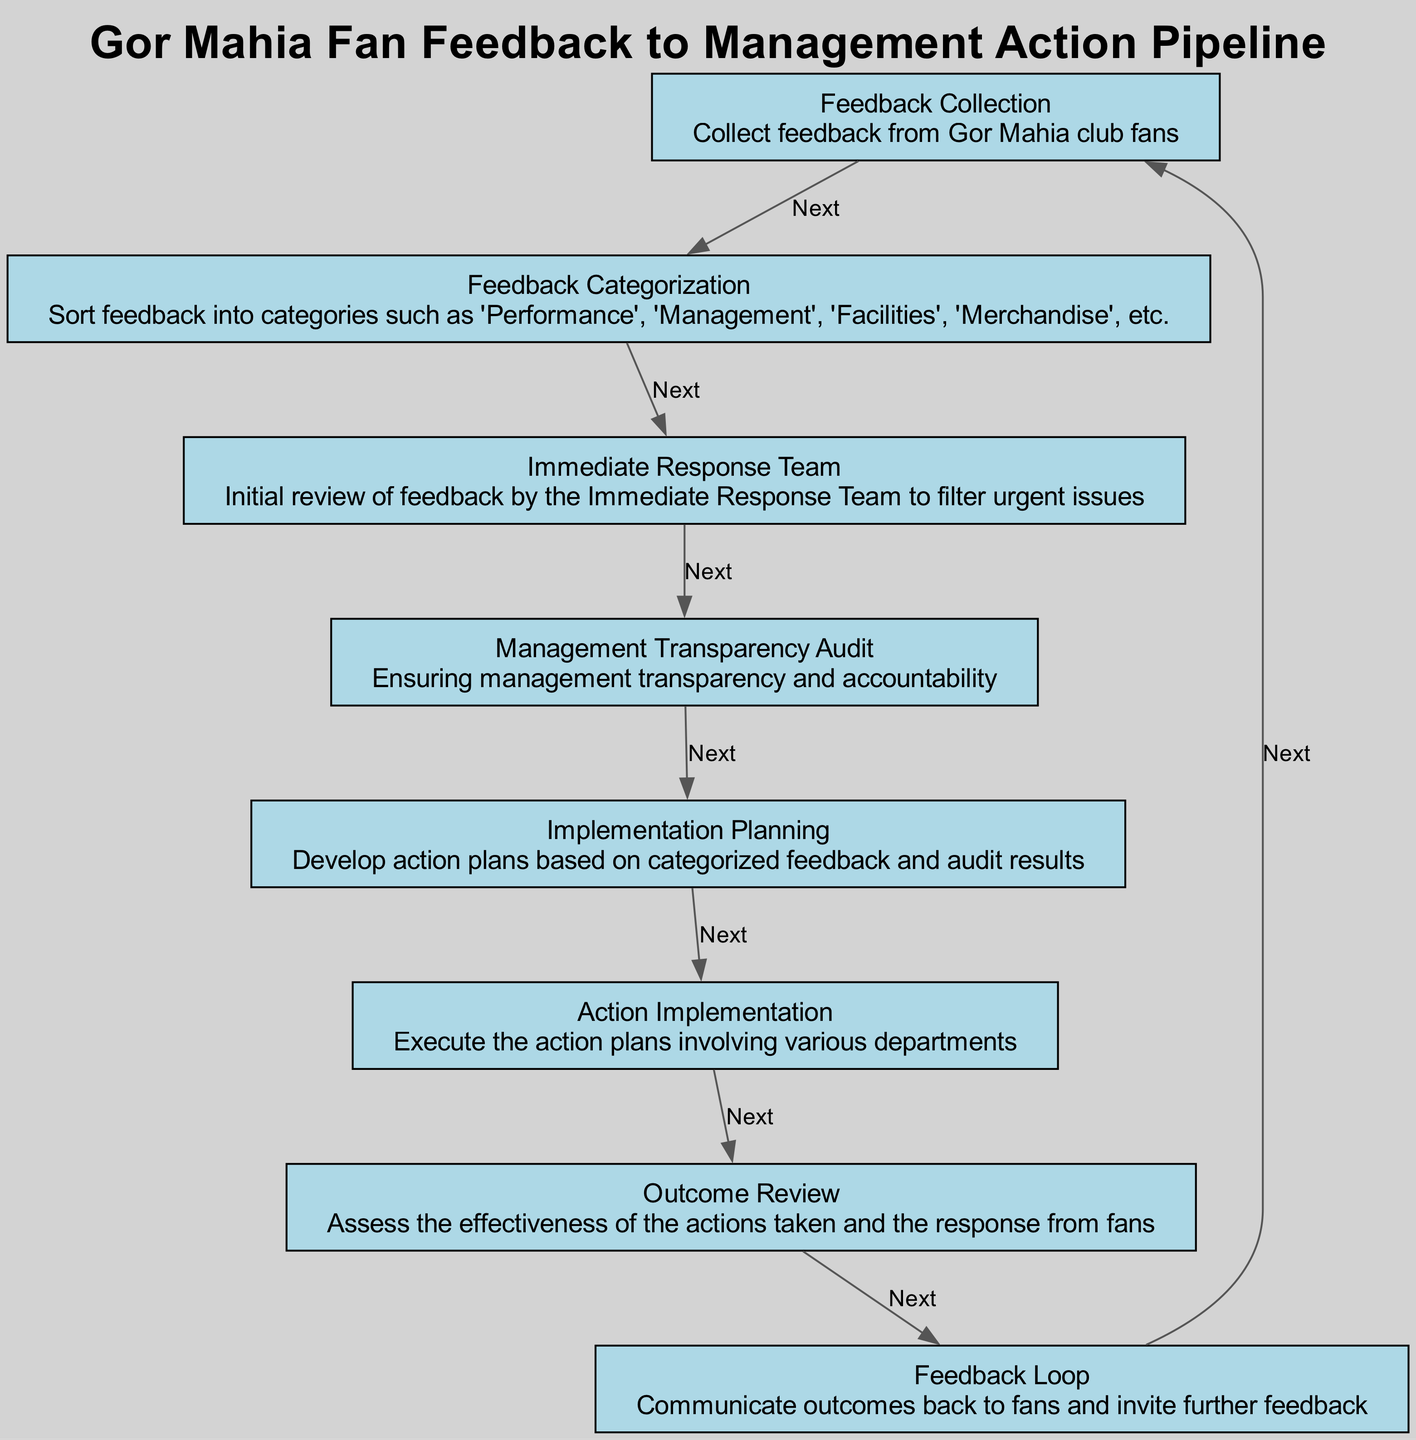What is the first step in the feedback pipeline? The first step in the feedback pipeline, as indicated in the diagram, is "Feedback Collection." This is the initial phase where feedback from Gor Mahia club fans is gathered.
Answer: Feedback Collection How many steps are there in the pipeline? The diagram shows a total of 8 steps represented by the elements going from feedback collection to feedback loop. Each element corresponds to a unique step in the process.
Answer: 8 What is the purpose of the Management Transparency Audit? The Management Transparency Audit, noted in the diagram, is to ensure management transparency and accountability in responding to fan feedback. This step seeks to build trust with the fans by making sure management acts transparently.
Answer: Ensuring management transparency and accountability Which step comes after Action Implementation? Action Implementation is followed by Outcome Review, where the effectiveness of the implemented actions is assessed alongside fan responses. This connection shows the flow of feedback processes leading to review and assessment of actions.
Answer: Outcome Review What type of feedback is sorted in the Feedback Categorization step? The Feedback Categorization step sorts feedback into categories like 'Performance', 'Management', 'Facilities', and 'Merchandise', as defined in the diagram. This step helps in simplifying the analysis of the feedback received.
Answer: Performance, Management, Facilities, Merchandise What happens during the Outcome Review phase? In the Outcome Review phase, the diagram specifies that the effectiveness of the actions taken is assessed, alongside evaluating the response from fans. This step aggregates data to determine if the feedback loop has successfully led to satisfactory changes.
Answer: Assess the effectiveness of the actions taken and the response from fans What connects the Feedback Loop back to Feedback Collection? The Feedback Loop communicates outcomes back to fans and invites further feedback, which indicates a continuous improvement process. This cycle illustrates the importance of keeping fans engaged and informed about actions taken regarding their feedback.
Answer: Communicate outcomes back to fans and invite further feedback How does the Immediate Response Team function in the process? The Immediate Response Team reviews feedback to filter out urgent issues, which informs the management about critical matters that require prompt attention. This function aids in prioritizing responses based on fan concerns.
Answer: Initial review of feedback by the Immediate Response Team to filter urgent issues What is the flow direction of the pipeline? The flow direction of the pipeline is from top to bottom, as indicated by the arrangement of the steps in the diagram. This sequential order allows for a clear understanding of the processes from feedback collection to implementation and review.
Answer: Top to bottom 